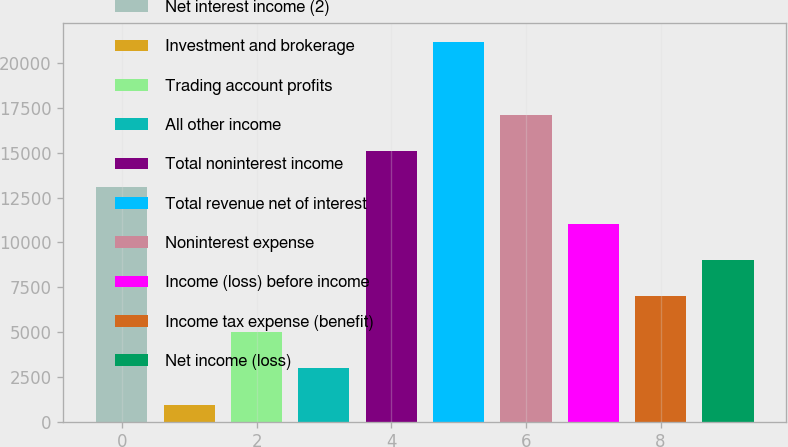Convert chart to OTSL. <chart><loc_0><loc_0><loc_500><loc_500><bar_chart><fcel>Net interest income (2)<fcel>Investment and brokerage<fcel>Trading account profits<fcel>All other income<fcel>Total noninterest income<fcel>Total revenue net of interest<fcel>Noninterest expense<fcel>Income (loss) before income<fcel>Income tax expense (benefit)<fcel>Net income (loss)<nl><fcel>13073.4<fcel>942<fcel>4985.8<fcel>2963.9<fcel>15095.3<fcel>21161<fcel>17117.2<fcel>11051.5<fcel>7007.7<fcel>9029.6<nl></chart> 